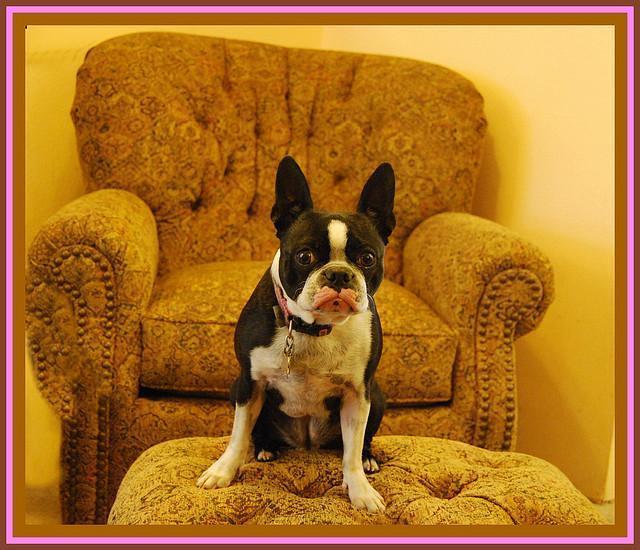How many men are playing?
Give a very brief answer. 0. 